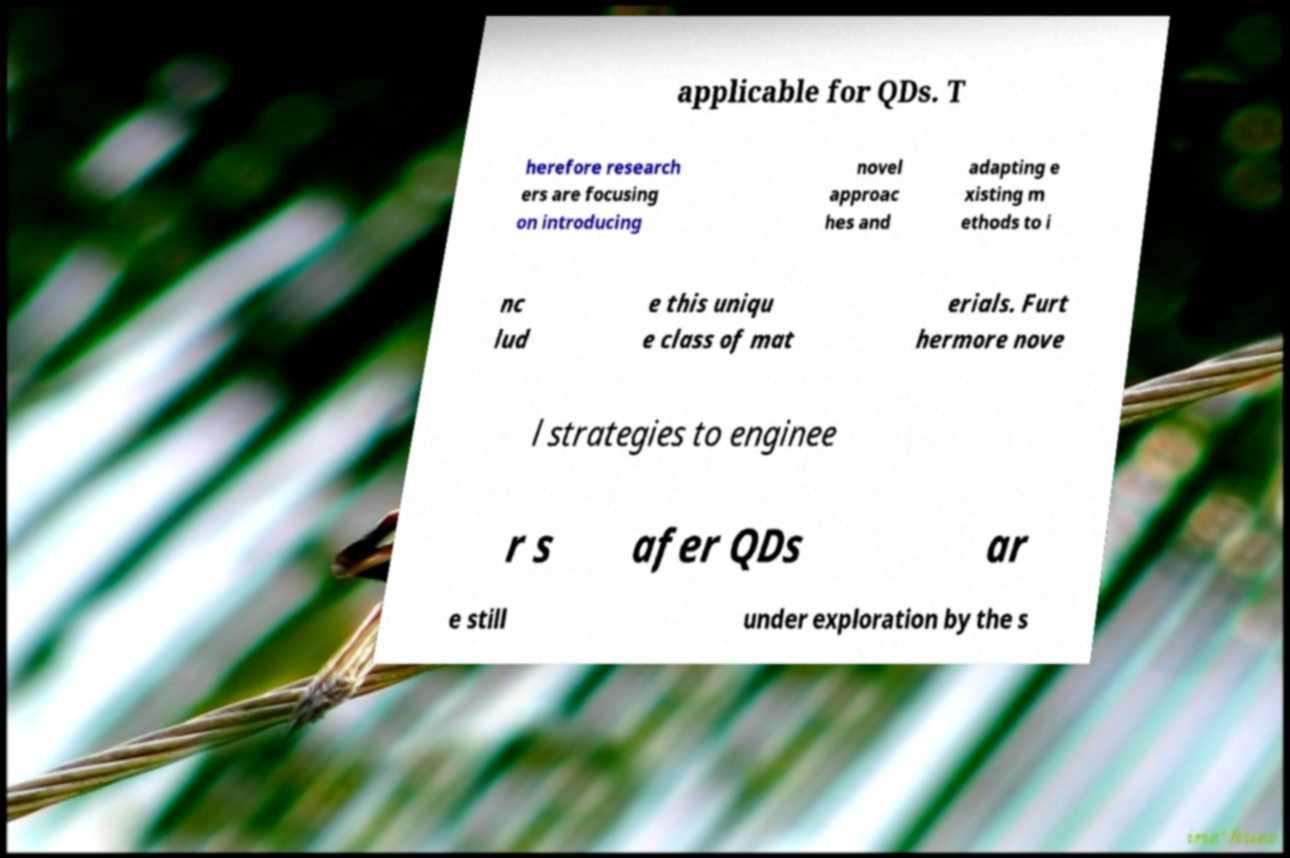Could you assist in decoding the text presented in this image and type it out clearly? applicable for QDs. T herefore research ers are focusing on introducing novel approac hes and adapting e xisting m ethods to i nc lud e this uniqu e class of mat erials. Furt hermore nove l strategies to enginee r s afer QDs ar e still under exploration by the s 